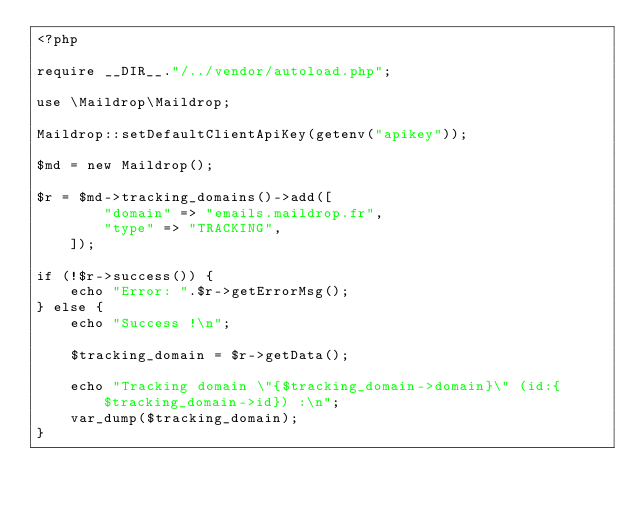Convert code to text. <code><loc_0><loc_0><loc_500><loc_500><_PHP_><?php

require __DIR__."/../vendor/autoload.php";

use \Maildrop\Maildrop;

Maildrop::setDefaultClientApiKey(getenv("apikey"));

$md = new Maildrop();

$r = $md->tracking_domains()->add([
        "domain" => "emails.maildrop.fr",
        "type" => "TRACKING",
    ]);

if (!$r->success()) {
    echo "Error: ".$r->getErrorMsg();
} else {
    echo "Success !\n";

    $tracking_domain = $r->getData();

    echo "Tracking domain \"{$tracking_domain->domain}\" (id:{$tracking_domain->id}) :\n";
    var_dump($tracking_domain);
}
</code> 